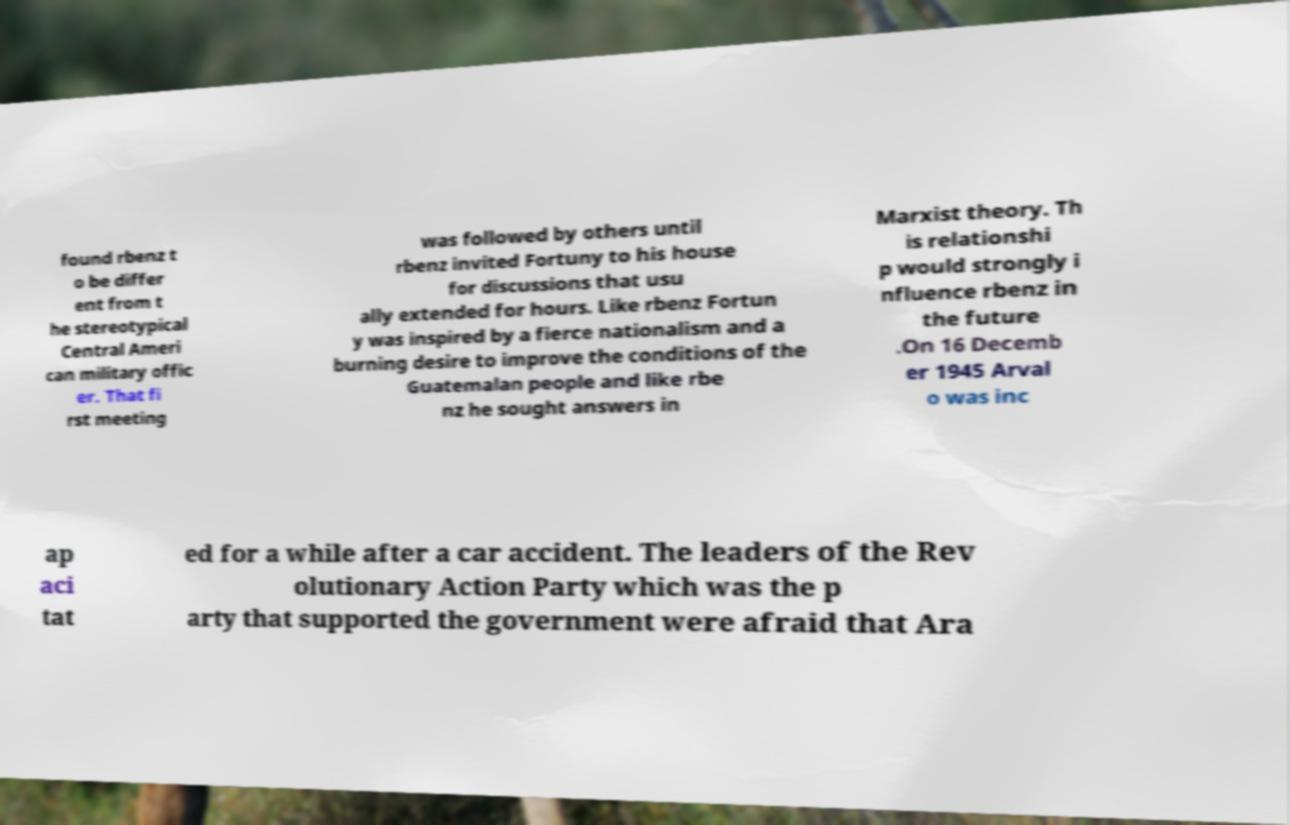Can you accurately transcribe the text from the provided image for me? found rbenz t o be differ ent from t he stereotypical Central Ameri can military offic er. That fi rst meeting was followed by others until rbenz invited Fortuny to his house for discussions that usu ally extended for hours. Like rbenz Fortun y was inspired by a fierce nationalism and a burning desire to improve the conditions of the Guatemalan people and like rbe nz he sought answers in Marxist theory. Th is relationshi p would strongly i nfluence rbenz in the future .On 16 Decemb er 1945 Arval o was inc ap aci tat ed for a while after a car accident. The leaders of the Rev olutionary Action Party which was the p arty that supported the government were afraid that Ara 